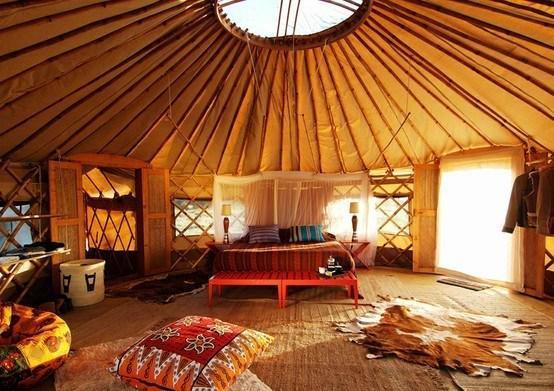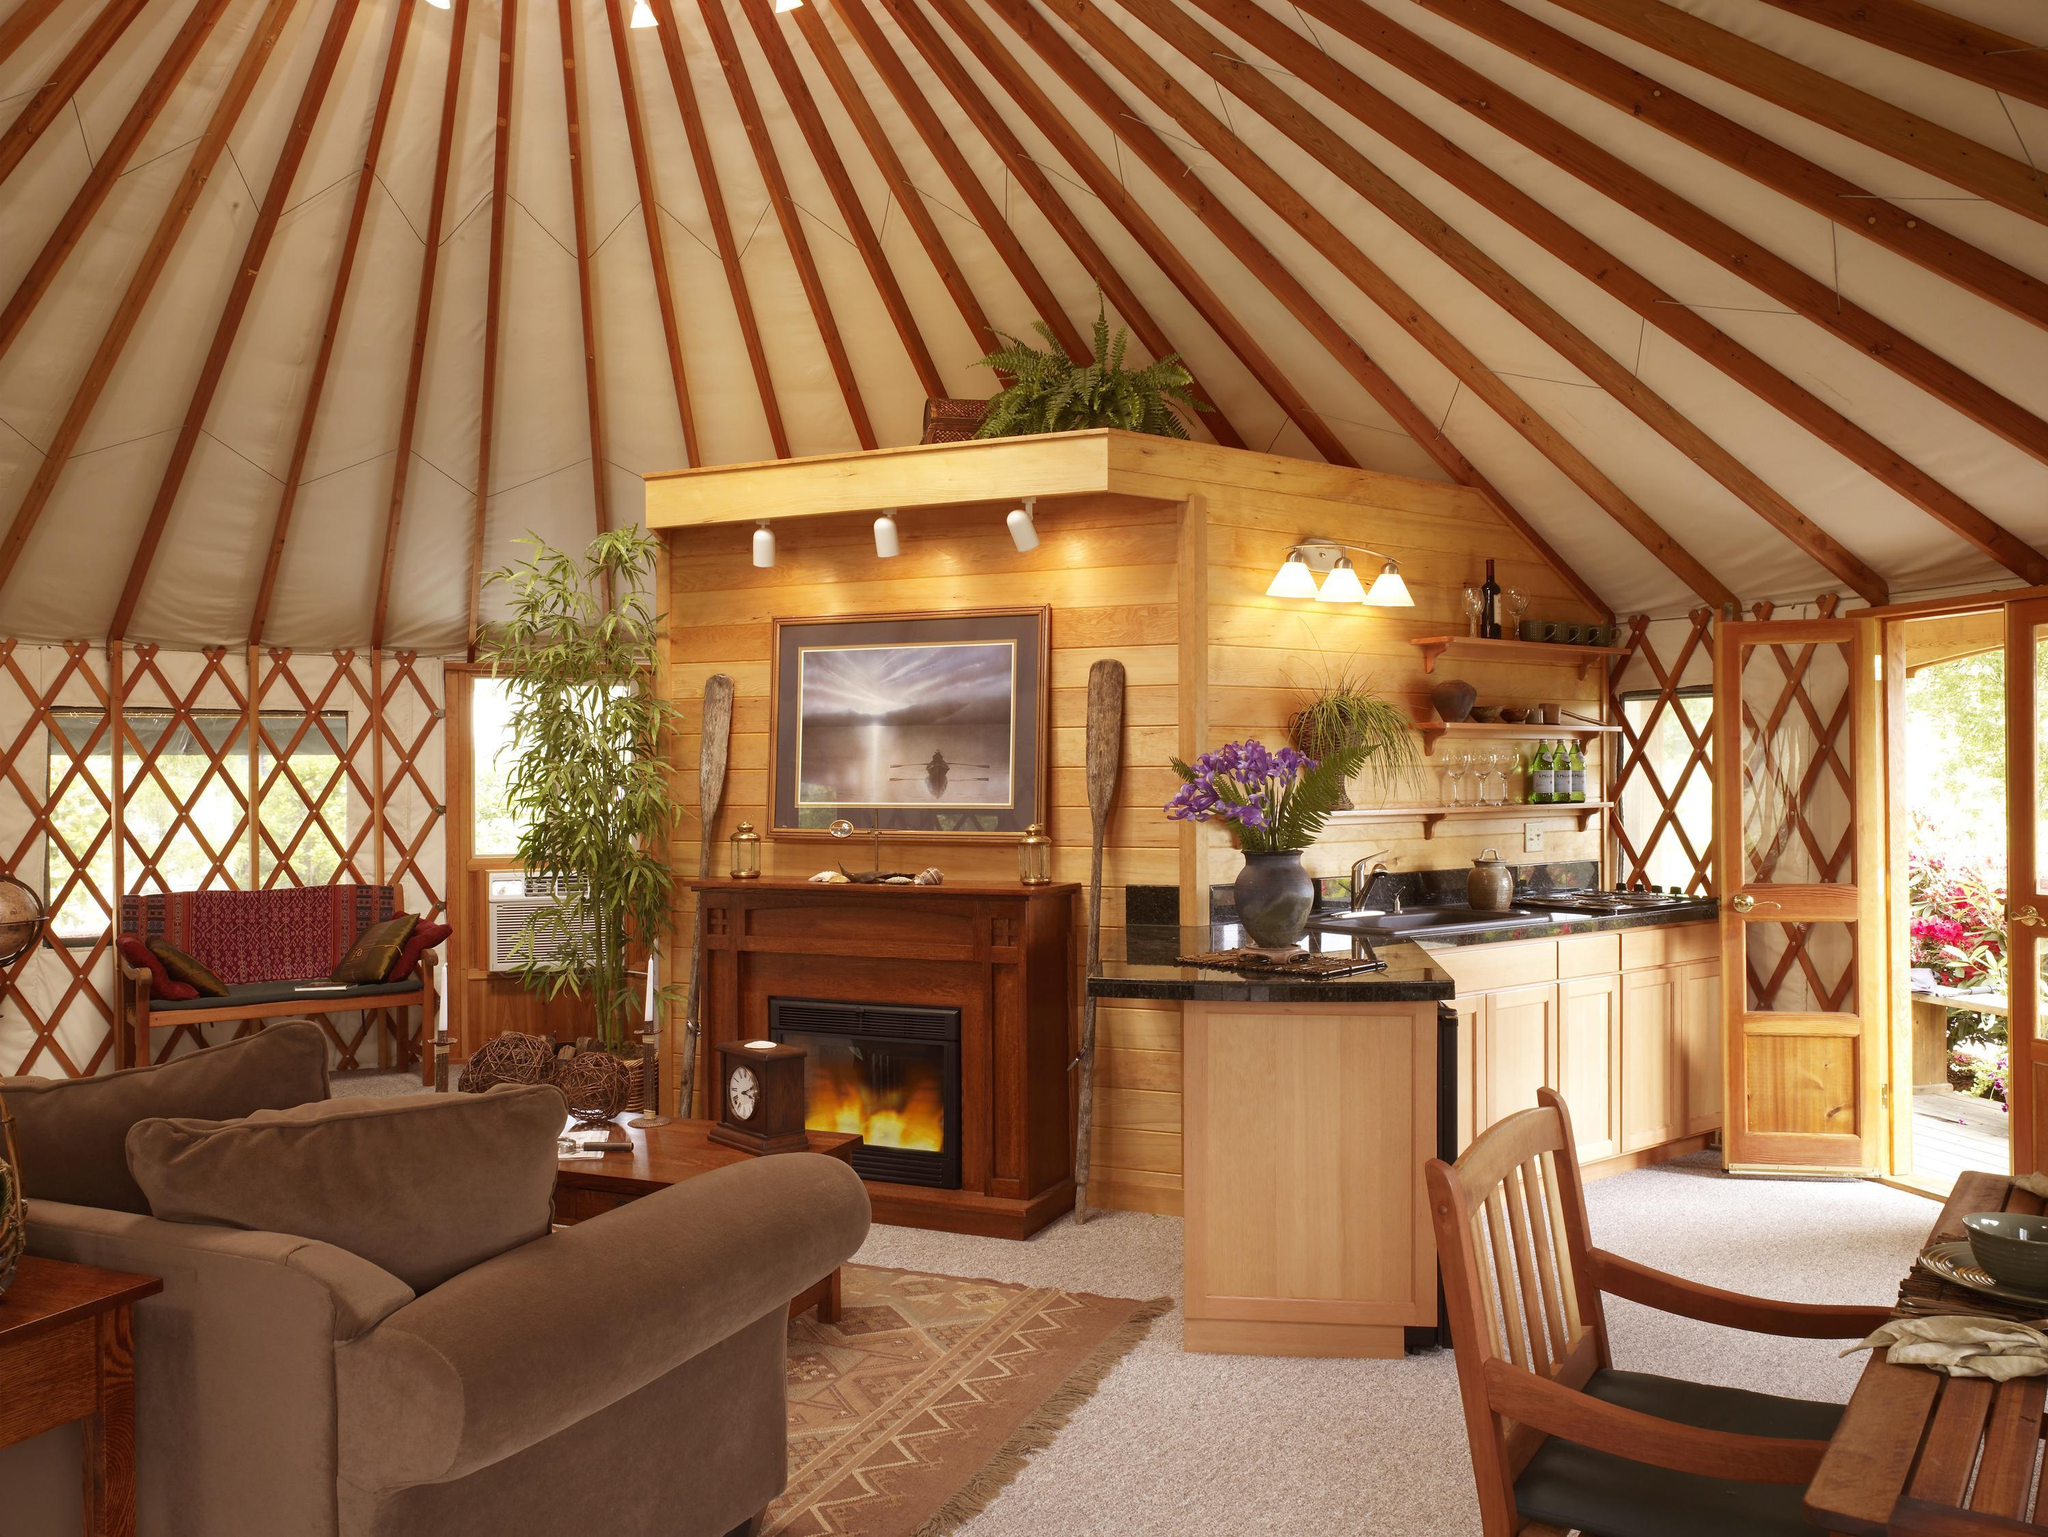The first image is the image on the left, the second image is the image on the right. Examine the images to the left and right. Is the description "A room with a fan-like ceiling contains an over-stuffed beige couch facing a fireplace with flame-glow in it." accurate? Answer yes or no. Yes. 